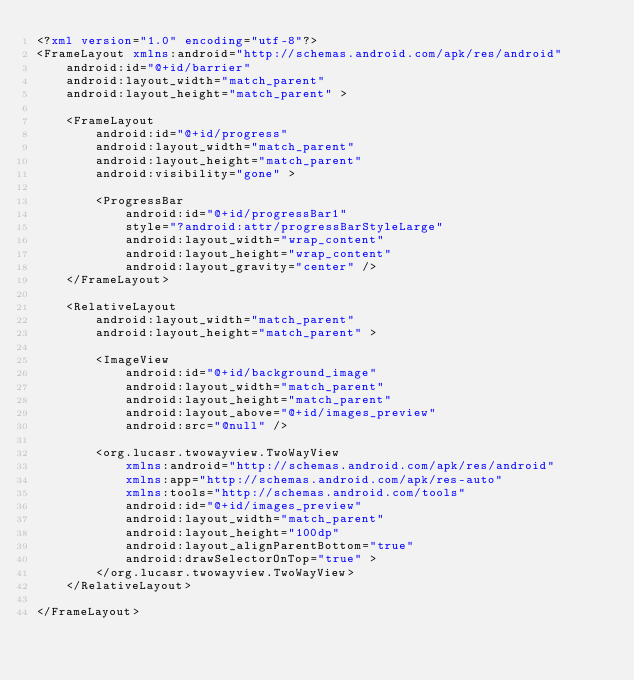Convert code to text. <code><loc_0><loc_0><loc_500><loc_500><_XML_><?xml version="1.0" encoding="utf-8"?>
<FrameLayout xmlns:android="http://schemas.android.com/apk/res/android"
    android:id="@+id/barrier"
    android:layout_width="match_parent"
    android:layout_height="match_parent" >

    <FrameLayout
        android:id="@+id/progress"
        android:layout_width="match_parent"
        android:layout_height="match_parent"
        android:visibility="gone" >

        <ProgressBar
            android:id="@+id/progressBar1"
            style="?android:attr/progressBarStyleLarge"
            android:layout_width="wrap_content"
            android:layout_height="wrap_content"
            android:layout_gravity="center" />
    </FrameLayout>

    <RelativeLayout
        android:layout_width="match_parent"
        android:layout_height="match_parent" >

        <ImageView
            android:id="@+id/background_image"
            android:layout_width="match_parent"
            android:layout_height="match_parent"
            android:layout_above="@+id/images_preview"
            android:src="@null" />

        <org.lucasr.twowayview.TwoWayView
            xmlns:android="http://schemas.android.com/apk/res/android"
            xmlns:app="http://schemas.android.com/apk/res-auto"
            xmlns:tools="http://schemas.android.com/tools"
            android:id="@+id/images_preview"
            android:layout_width="match_parent"
            android:layout_height="100dp"
            android:layout_alignParentBottom="true"
            android:drawSelectorOnTop="true" >
        </org.lucasr.twowayview.TwoWayView>
    </RelativeLayout>

</FrameLayout>
</code> 